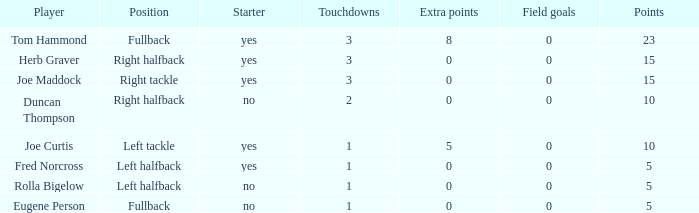What is the average number of field goals scored by a right halfback who had more than 3 touchdowns? None. 